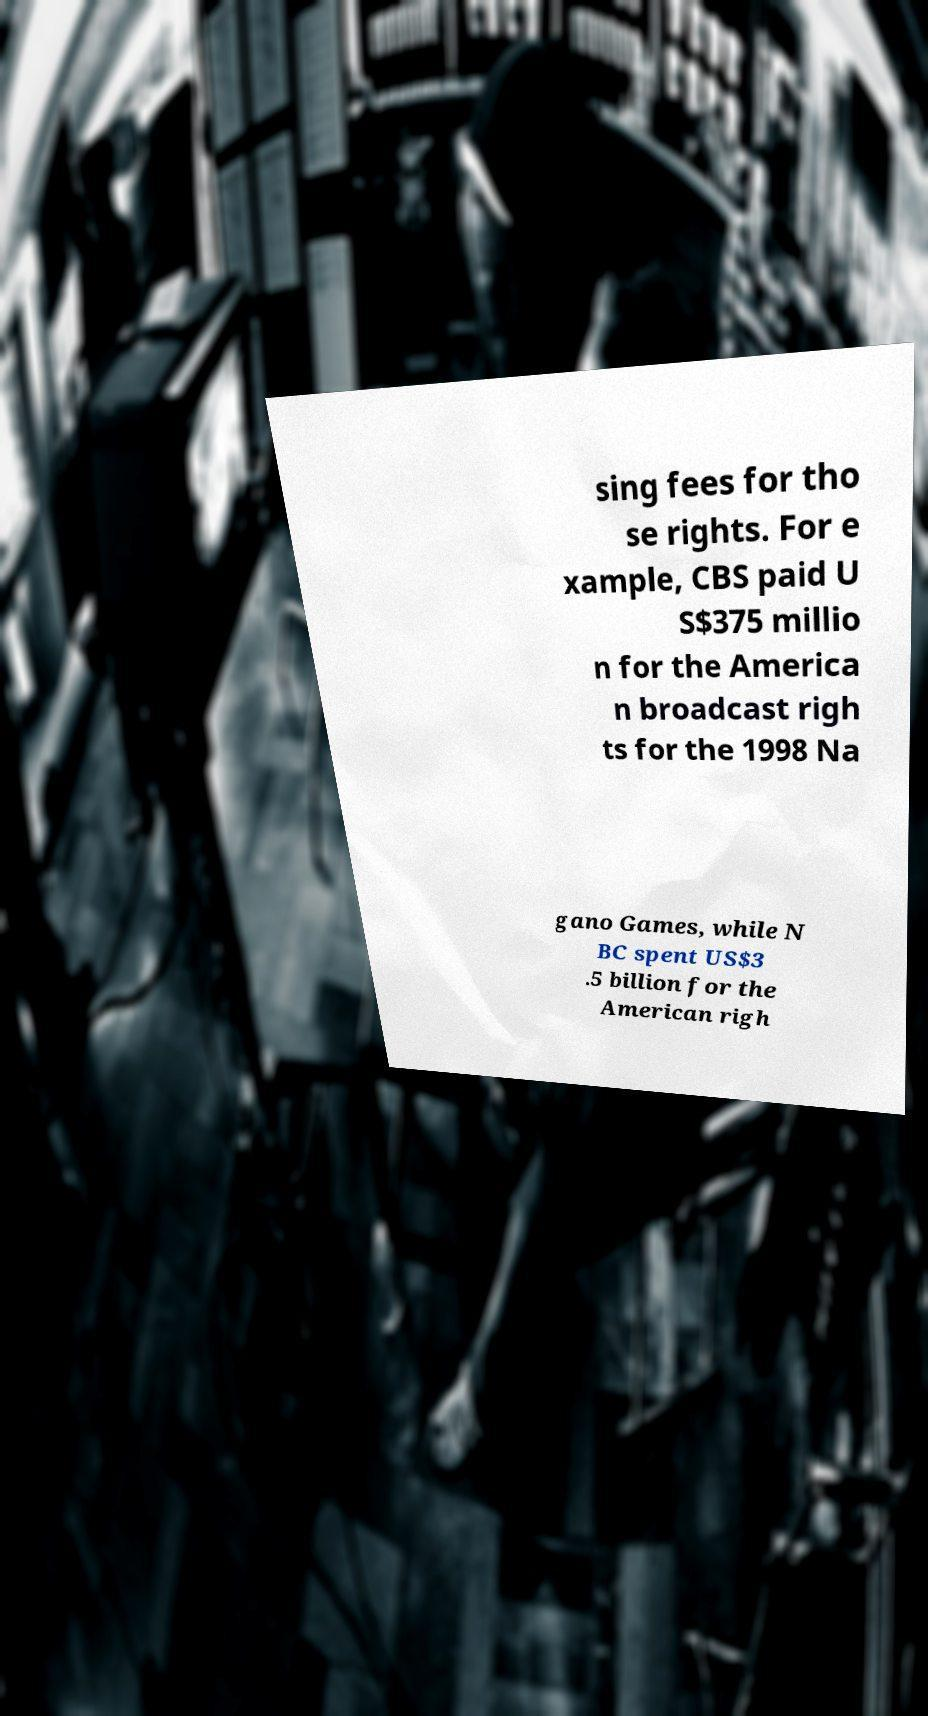I need the written content from this picture converted into text. Can you do that? sing fees for tho se rights. For e xample, CBS paid U S$375 millio n for the America n broadcast righ ts for the 1998 Na gano Games, while N BC spent US$3 .5 billion for the American righ 